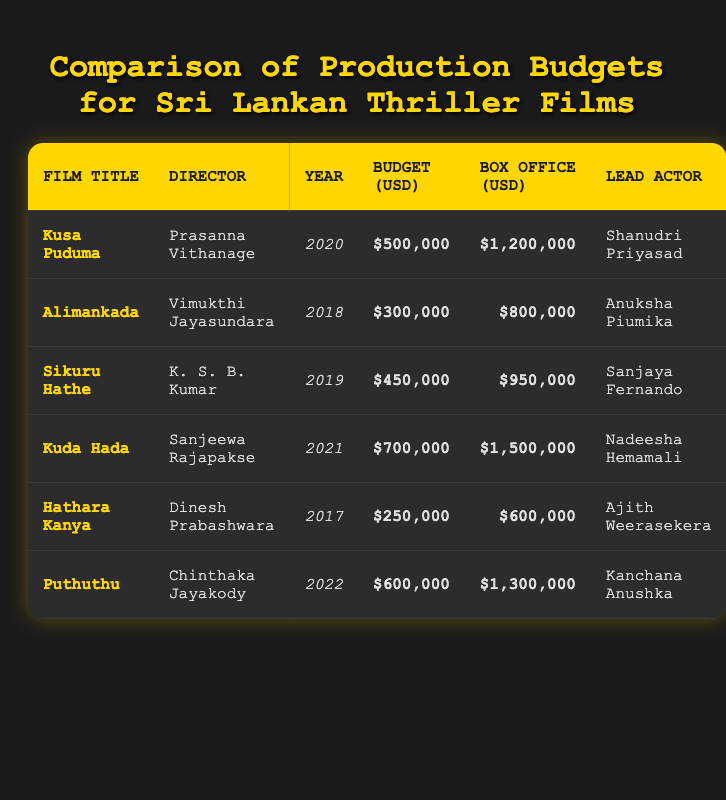What is the budget of "Kuda Hada"? You can find the row for "Kuda Hada" in the table. The budget value listed there is $700,000.
Answer: $700,000 Which film had the highest box office earnings? By checking the box office earnings in the table, "Kuda Hada" shows the highest earnings of $1,500,000 compared to other films.
Answer: $1,500,000 What is the total budget of all the films listed? To find the total budget, add all the budget values: $500,000 + $300,000 + $450,000 + $700,000 + $250,000 + $600,000 = $2,800,000.
Answer: $2,800,000 Which film directed by "Vimukthi Jayasundara" has the lowest budget? The film directed by "Vimukthi Jayasundara" is "Alimankada" with a budget of $300,000, the lowest among all listed films.
Answer: $300,000 Did "Hathara Kanya" earn more than its budget? Yes, "Hathara Kanya" had a budget of $250,000 and box office earnings of $600,000, which are higher than the budget.
Answer: Yes What is the average budget of the films produced in 2020 and later? The films from 2020 and later are "Kusa Puduma" ($500,000), "Kuda Hada" ($700,000), and "Puthuthu" ($600,000). Adding these gives $1,800,000, and dividing by 3 yields an average of $600,000.
Answer: $600,000 Which film had the largest budget increase compared to its box office earnings? Calculate the difference between box office earnings and budget for each film: "Hathara Kanya": $600,000 - $250,000 = $350,000; "Alimankada": $800,000 - $300,000 = $500,000; "Sikuru Hathe": $950,000 - $450,000 = $500,000; "Kusa Puduma": $1,200,000 - $500,000 = $700,000; "Kuda Hada": $1,500,000 - $700,000 = $800,000; "Puthuthu": $1,300,000 - $600,000 = $700,000.  "Kuda Hada" had the largest increase of $800,000.
Answer: "Kuda Hada" Which film's budget was less than half of its box office earnings? Evaluate the box office earnings and budget: "Hathara Kanya" ($250,000 budget and $600,000 earnings), "Alimankada" ($300,000 budget and $800,000 earnings) both meet this condition, as they each earned more than double their budget.
Answer: "Hathara Kanya" and "Alimankada" 